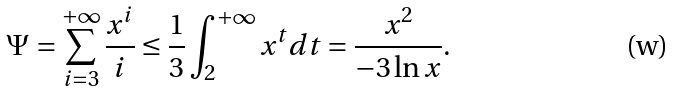Convert formula to latex. <formula><loc_0><loc_0><loc_500><loc_500>\Psi & = \sum _ { i = 3 } ^ { + \infty } \frac { x ^ { i } } { i } \leq \frac { 1 } { 3 } \int _ { 2 } ^ { + \infty } x ^ { t } d t = \frac { x ^ { 2 } } { - 3 \ln x } .</formula> 